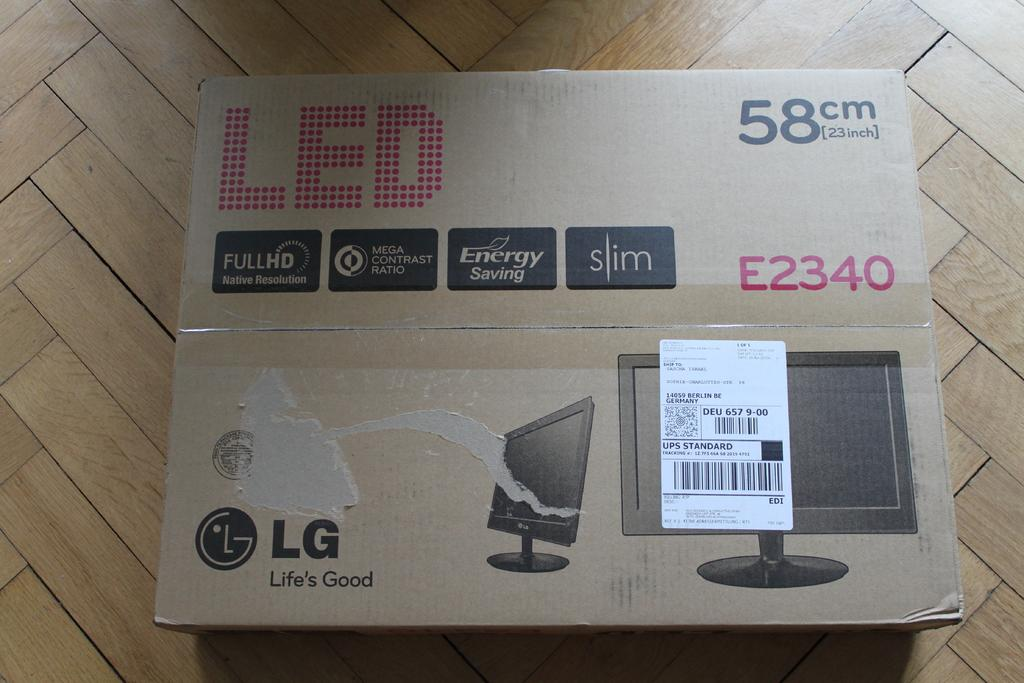<image>
Describe the image concisely. An LG LED TV remains unopened in its box on the floor. 